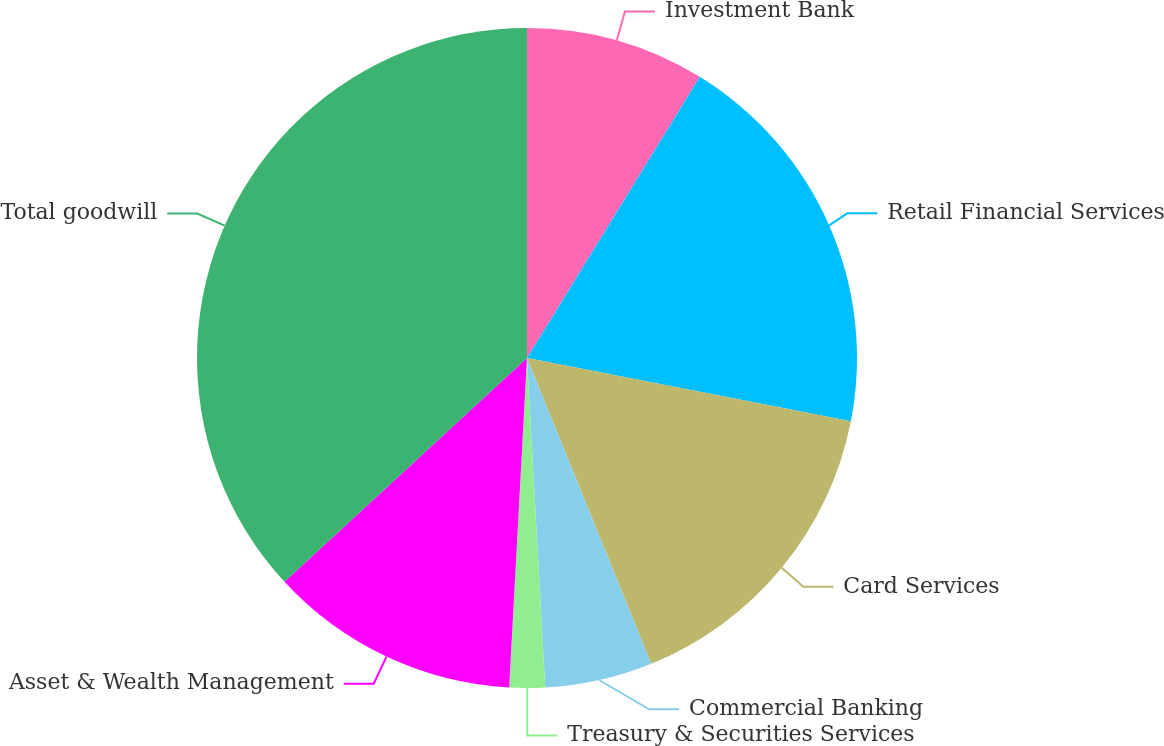Convert chart. <chart><loc_0><loc_0><loc_500><loc_500><pie_chart><fcel>Investment Bank<fcel>Retail Financial Services<fcel>Card Services<fcel>Commercial Banking<fcel>Treasury & Securities Services<fcel>Asset & Wealth Management<fcel>Total goodwill<nl><fcel>8.77%<fcel>19.3%<fcel>15.79%<fcel>5.26%<fcel>1.74%<fcel>12.28%<fcel>36.86%<nl></chart> 